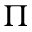<formula> <loc_0><loc_0><loc_500><loc_500>\Pi</formula> 